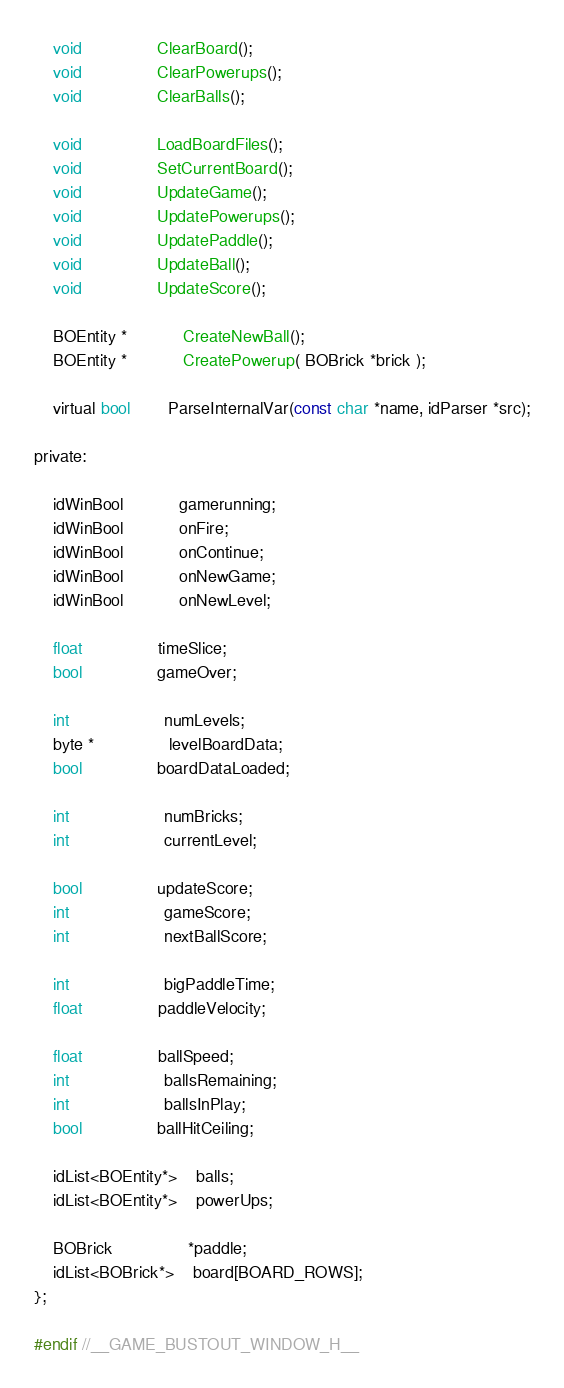<code> <loc_0><loc_0><loc_500><loc_500><_C_>	void				ClearBoard();
	void				ClearPowerups();
	void				ClearBalls();

	void				LoadBoardFiles();
	void				SetCurrentBoard();
	void				UpdateGame();
	void				UpdatePowerups();
	void				UpdatePaddle();
	void				UpdateBall();
	void				UpdateScore();

	BOEntity *			CreateNewBall();
	BOEntity *			CreatePowerup( BOBrick *brick );

	virtual bool		ParseInternalVar(const char *name, idParser *src);

private:

	idWinBool			gamerunning;
	idWinBool			onFire;
	idWinBool			onContinue;
	idWinBool			onNewGame;
	idWinBool			onNewLevel;

	float				timeSlice;
	bool				gameOver;

	int					numLevels;
	byte *				levelBoardData;
	bool				boardDataLoaded;

	int					numBricks;
	int					currentLevel;

	bool				updateScore;
	int					gameScore;
	int					nextBallScore;

	int					bigPaddleTime;
	float				paddleVelocity;

	float				ballSpeed;
	int					ballsRemaining;
	int					ballsInPlay;
	bool				ballHitCeiling;

	idList<BOEntity*>	balls;
	idList<BOEntity*>	powerUps;

	BOBrick				*paddle;
	idList<BOBrick*>	board[BOARD_ROWS];
};

#endif //__GAME_BUSTOUT_WINDOW_H__
</code> 